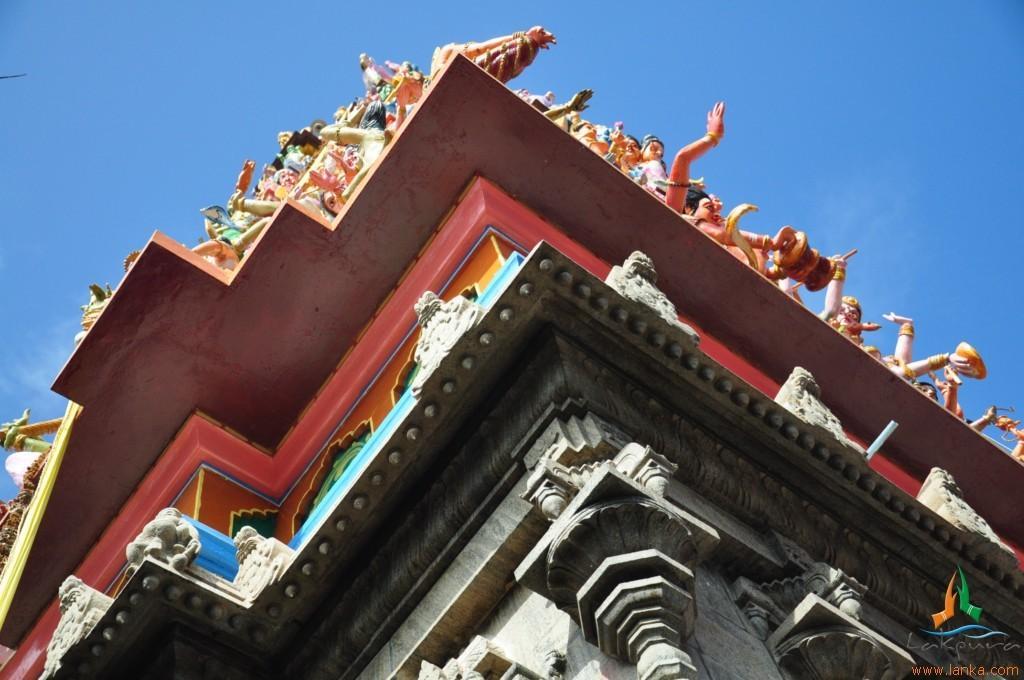How would you summarize this image in a sentence or two? At the bottom of the image we can see a temple, on the temple we can see some sculptures. At the top of the image we can see the sky. 